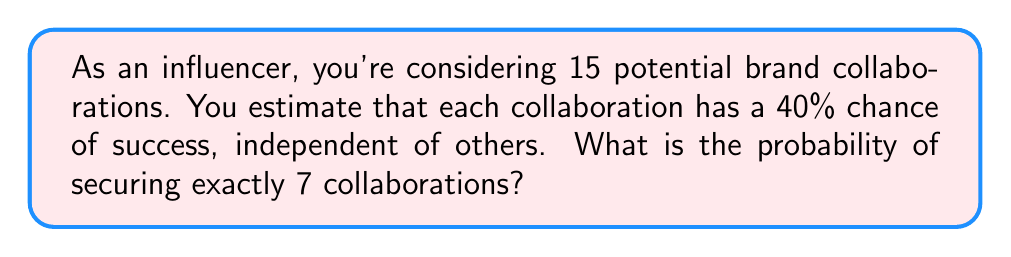What is the answer to this math problem? To solve this problem, we'll use the binomial probability distribution:

1) The binomial probability formula is:

   $$P(X = k) = \binom{n}{k} p^k (1-p)^{n-k}$$

   Where:
   $n$ = number of trials (potential collaborations)
   $k$ = number of successes (secured collaborations)
   $p$ = probability of success for each trial

2) In this case:
   $n = 15$
   $k = 7$
   $p = 0.40$

3) Let's calculate each part:

   a) $\binom{15}{7} = \frac{15!}{7!(15-7)!} = \frac{15!}{7!8!} = 6435$

   b) $p^k = 0.40^7 \approx 0.0016384$

   c) $(1-p)^{n-k} = 0.60^8 \approx 0.0168$

4) Now, let's put it all together:

   $$P(X = 7) = 6435 \times 0.0016384 \times 0.0168 \approx 0.1766$$

5) Therefore, the probability of securing exactly 7 collaborations is approximately 0.1766 or 17.66%.
Answer: 0.1766 